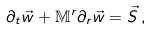<formula> <loc_0><loc_0><loc_500><loc_500>\partial _ { t } { \vec { w } } + \mathbb { M } ^ { r } \partial _ { r } { \vec { w } } = { \vec { S } } \, ,</formula> 